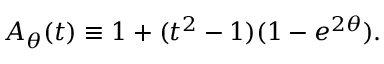Convert formula to latex. <formula><loc_0><loc_0><loc_500><loc_500>A _ { \theta } ( t ) \equiv 1 + ( t ^ { 2 } - 1 ) ( 1 - e ^ { 2 \theta } ) .</formula> 